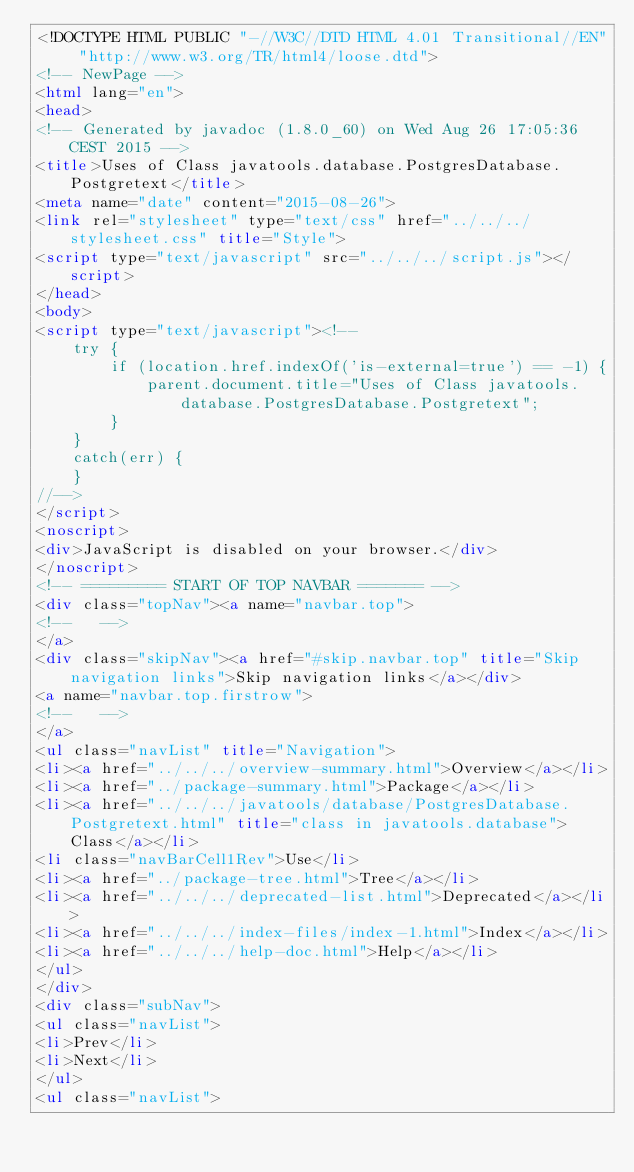<code> <loc_0><loc_0><loc_500><loc_500><_HTML_><!DOCTYPE HTML PUBLIC "-//W3C//DTD HTML 4.01 Transitional//EN" "http://www.w3.org/TR/html4/loose.dtd">
<!-- NewPage -->
<html lang="en">
<head>
<!-- Generated by javadoc (1.8.0_60) on Wed Aug 26 17:05:36 CEST 2015 -->
<title>Uses of Class javatools.database.PostgresDatabase.Postgretext</title>
<meta name="date" content="2015-08-26">
<link rel="stylesheet" type="text/css" href="../../../stylesheet.css" title="Style">
<script type="text/javascript" src="../../../script.js"></script>
</head>
<body>
<script type="text/javascript"><!--
    try {
        if (location.href.indexOf('is-external=true') == -1) {
            parent.document.title="Uses of Class javatools.database.PostgresDatabase.Postgretext";
        }
    }
    catch(err) {
    }
//-->
</script>
<noscript>
<div>JavaScript is disabled on your browser.</div>
</noscript>
<!-- ========= START OF TOP NAVBAR ======= -->
<div class="topNav"><a name="navbar.top">
<!--   -->
</a>
<div class="skipNav"><a href="#skip.navbar.top" title="Skip navigation links">Skip navigation links</a></div>
<a name="navbar.top.firstrow">
<!--   -->
</a>
<ul class="navList" title="Navigation">
<li><a href="../../../overview-summary.html">Overview</a></li>
<li><a href="../package-summary.html">Package</a></li>
<li><a href="../../../javatools/database/PostgresDatabase.Postgretext.html" title="class in javatools.database">Class</a></li>
<li class="navBarCell1Rev">Use</li>
<li><a href="../package-tree.html">Tree</a></li>
<li><a href="../../../deprecated-list.html">Deprecated</a></li>
<li><a href="../../../index-files/index-1.html">Index</a></li>
<li><a href="../../../help-doc.html">Help</a></li>
</ul>
</div>
<div class="subNav">
<ul class="navList">
<li>Prev</li>
<li>Next</li>
</ul>
<ul class="navList"></code> 